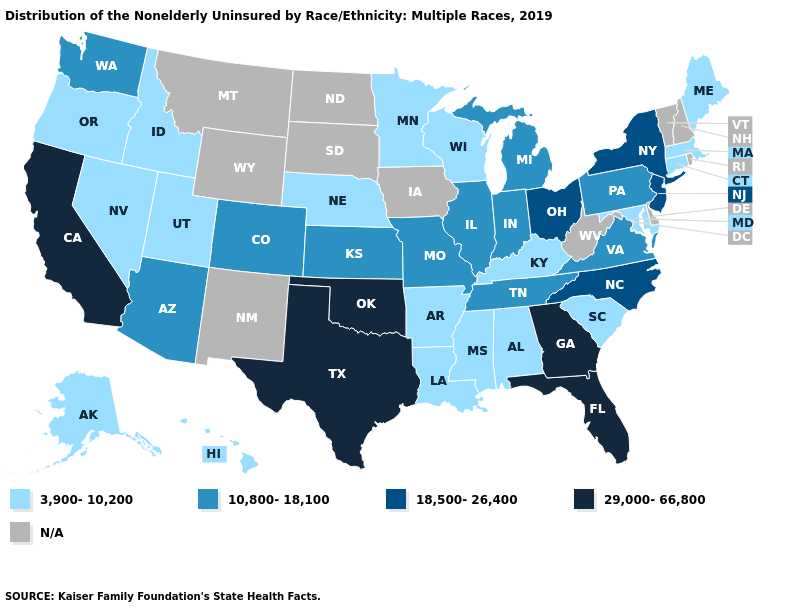What is the lowest value in the USA?
Answer briefly. 3,900-10,200. Which states have the highest value in the USA?
Short answer required. California, Florida, Georgia, Oklahoma, Texas. Does Hawaii have the lowest value in the USA?
Short answer required. Yes. What is the value of Wyoming?
Keep it brief. N/A. What is the value of New Jersey?
Be succinct. 18,500-26,400. What is the value of Arizona?
Write a very short answer. 10,800-18,100. Does California have the highest value in the USA?
Be succinct. Yes. What is the lowest value in the USA?
Quick response, please. 3,900-10,200. Is the legend a continuous bar?
Keep it brief. No. Name the states that have a value in the range 10,800-18,100?
Answer briefly. Arizona, Colorado, Illinois, Indiana, Kansas, Michigan, Missouri, Pennsylvania, Tennessee, Virginia, Washington. What is the value of Hawaii?
Short answer required. 3,900-10,200. Among the states that border Idaho , which have the lowest value?
Concise answer only. Nevada, Oregon, Utah. Among the states that border Oklahoma , which have the lowest value?
Give a very brief answer. Arkansas. What is the value of Hawaii?
Concise answer only. 3,900-10,200. 